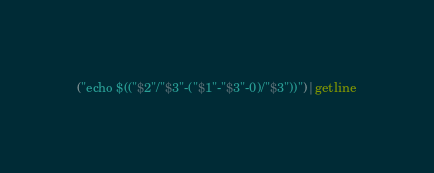Convert code to text. <code><loc_0><loc_0><loc_500><loc_500><_Awk_>("echo $(("$2"/"$3"-("$1"-"$3"-0)/"$3"))")|getline</code> 